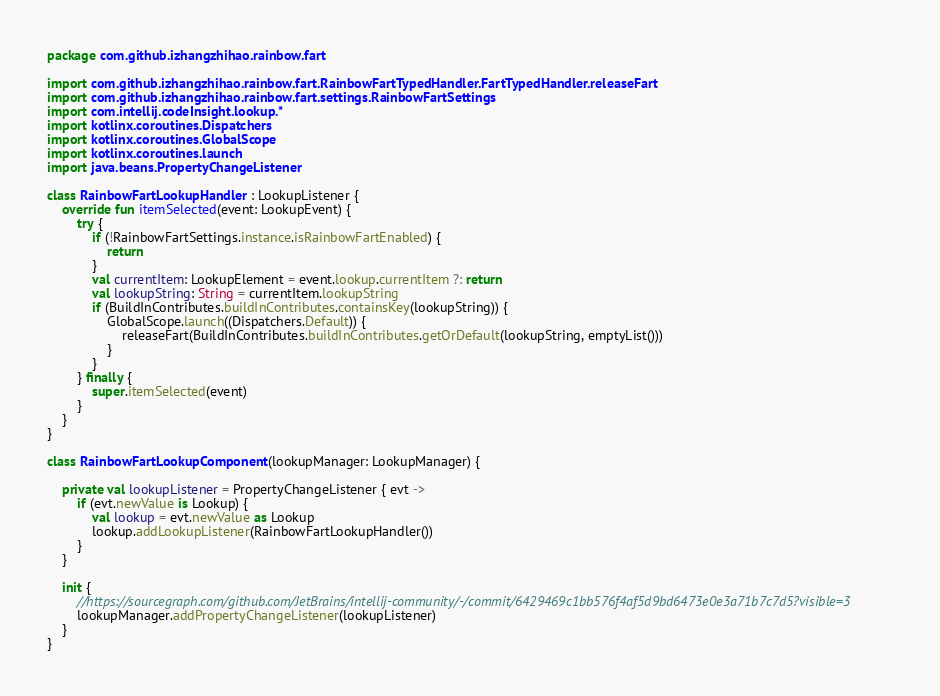Convert code to text. <code><loc_0><loc_0><loc_500><loc_500><_Kotlin_>package com.github.izhangzhihao.rainbow.fart

import com.github.izhangzhihao.rainbow.fart.RainbowFartTypedHandler.FartTypedHandler.releaseFart
import com.github.izhangzhihao.rainbow.fart.settings.RainbowFartSettings
import com.intellij.codeInsight.lookup.*
import kotlinx.coroutines.Dispatchers
import kotlinx.coroutines.GlobalScope
import kotlinx.coroutines.launch
import java.beans.PropertyChangeListener

class RainbowFartLookupHandler : LookupListener {
    override fun itemSelected(event: LookupEvent) {
        try {
            if (!RainbowFartSettings.instance.isRainbowFartEnabled) {
                return
            }
            val currentItem: LookupElement = event.lookup.currentItem ?: return
            val lookupString: String = currentItem.lookupString
            if (BuildInContributes.buildInContributes.containsKey(lookupString)) {
                GlobalScope.launch((Dispatchers.Default)) {
                    releaseFart(BuildInContributes.buildInContributes.getOrDefault(lookupString, emptyList()))
                }
            }
        } finally {
            super.itemSelected(event)
        }
    }
}

class RainbowFartLookupComponent(lookupManager: LookupManager) {

    private val lookupListener = PropertyChangeListener { evt ->
        if (evt.newValue is Lookup) {
            val lookup = evt.newValue as Lookup
            lookup.addLookupListener(RainbowFartLookupHandler())
        }
    }

    init {
        //https://sourcegraph.com/github.com/JetBrains/intellij-community/-/commit/6429469c1bb576f4af5d9bd6473e0e3a71b7c7d5?visible=3
        lookupManager.addPropertyChangeListener(lookupListener)
    }
}</code> 